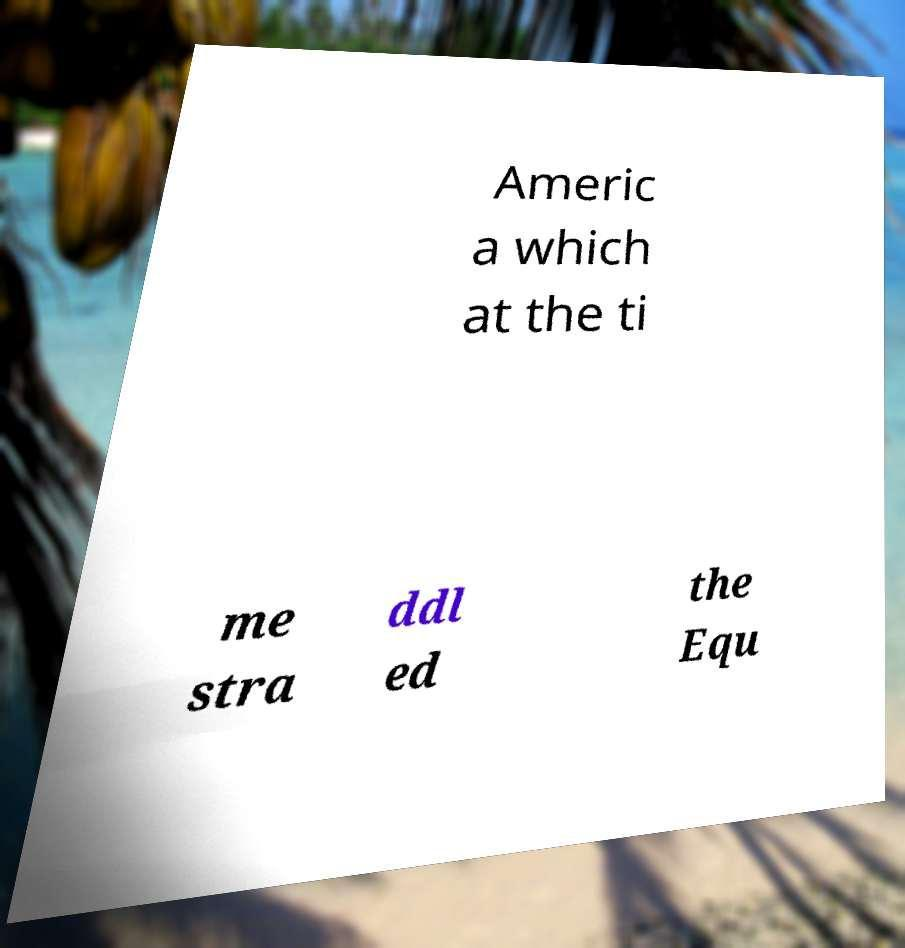Please read and relay the text visible in this image. What does it say? Americ a which at the ti me stra ddl ed the Equ 